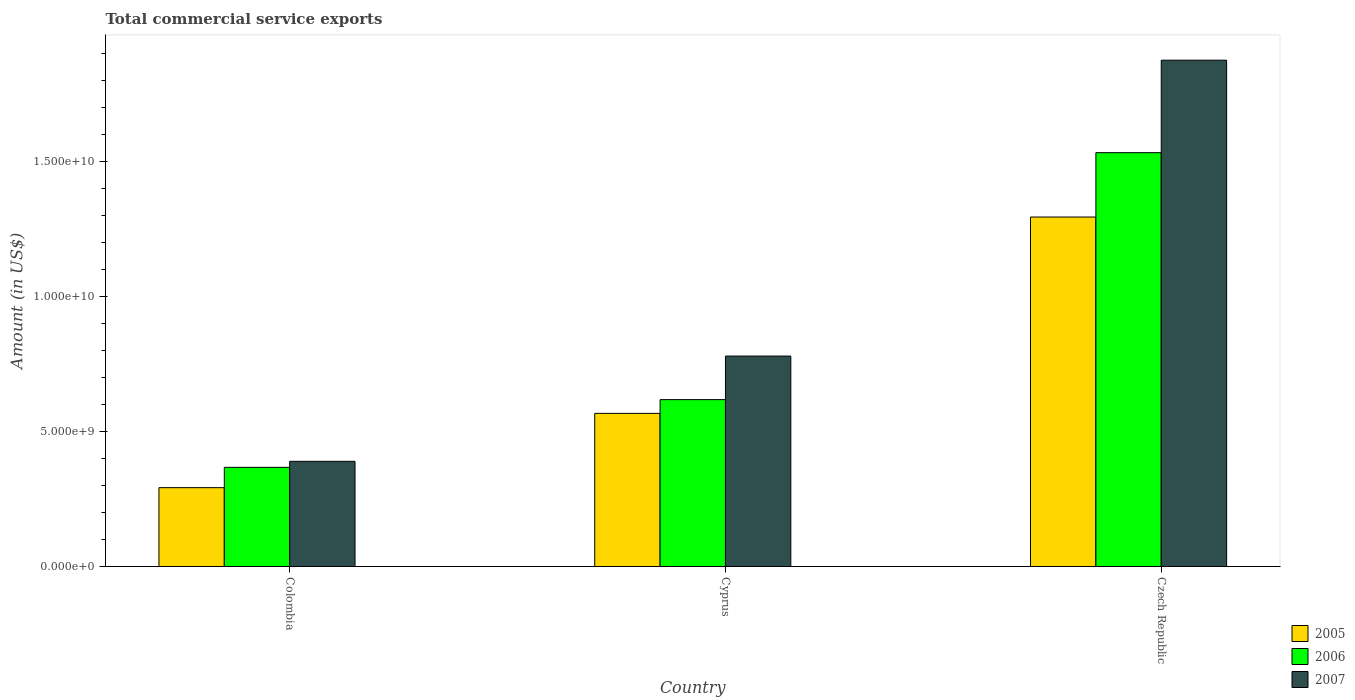Are the number of bars per tick equal to the number of legend labels?
Ensure brevity in your answer.  Yes. Are the number of bars on each tick of the X-axis equal?
Your answer should be compact. Yes. How many bars are there on the 2nd tick from the right?
Your response must be concise. 3. What is the label of the 3rd group of bars from the left?
Provide a short and direct response. Czech Republic. What is the total commercial service exports in 2007 in Colombia?
Your answer should be compact. 3.90e+09. Across all countries, what is the maximum total commercial service exports in 2005?
Provide a succinct answer. 1.30e+1. Across all countries, what is the minimum total commercial service exports in 2007?
Provide a succinct answer. 3.90e+09. In which country was the total commercial service exports in 2006 maximum?
Provide a succinct answer. Czech Republic. What is the total total commercial service exports in 2005 in the graph?
Provide a short and direct response. 2.16e+1. What is the difference between the total commercial service exports in 2007 in Cyprus and that in Czech Republic?
Offer a very short reply. -1.10e+1. What is the difference between the total commercial service exports in 2005 in Colombia and the total commercial service exports in 2006 in Czech Republic?
Your response must be concise. -1.24e+1. What is the average total commercial service exports in 2005 per country?
Provide a succinct answer. 7.18e+09. What is the difference between the total commercial service exports of/in 2006 and total commercial service exports of/in 2005 in Czech Republic?
Ensure brevity in your answer.  2.39e+09. In how many countries, is the total commercial service exports in 2007 greater than 9000000000 US$?
Give a very brief answer. 1. What is the ratio of the total commercial service exports in 2007 in Colombia to that in Cyprus?
Ensure brevity in your answer.  0.5. Is the total commercial service exports in 2005 in Cyprus less than that in Czech Republic?
Offer a terse response. Yes. Is the difference between the total commercial service exports in 2006 in Colombia and Cyprus greater than the difference between the total commercial service exports in 2005 in Colombia and Cyprus?
Provide a succinct answer. Yes. What is the difference between the highest and the second highest total commercial service exports in 2005?
Your response must be concise. 2.75e+09. What is the difference between the highest and the lowest total commercial service exports in 2006?
Offer a very short reply. 1.17e+1. What does the 3rd bar from the right in Colombia represents?
Provide a succinct answer. 2005. Is it the case that in every country, the sum of the total commercial service exports in 2005 and total commercial service exports in 2007 is greater than the total commercial service exports in 2006?
Provide a succinct answer. Yes. How many bars are there?
Give a very brief answer. 9. What is the difference between two consecutive major ticks on the Y-axis?
Make the answer very short. 5.00e+09. Are the values on the major ticks of Y-axis written in scientific E-notation?
Provide a succinct answer. Yes. Does the graph contain grids?
Your answer should be very brief. No. What is the title of the graph?
Keep it short and to the point. Total commercial service exports. What is the Amount (in US$) in 2005 in Colombia?
Your response must be concise. 2.92e+09. What is the Amount (in US$) of 2006 in Colombia?
Offer a very short reply. 3.68e+09. What is the Amount (in US$) in 2007 in Colombia?
Offer a very short reply. 3.90e+09. What is the Amount (in US$) of 2005 in Cyprus?
Give a very brief answer. 5.68e+09. What is the Amount (in US$) of 2006 in Cyprus?
Offer a very short reply. 6.19e+09. What is the Amount (in US$) in 2007 in Cyprus?
Offer a terse response. 7.80e+09. What is the Amount (in US$) of 2005 in Czech Republic?
Give a very brief answer. 1.30e+1. What is the Amount (in US$) in 2006 in Czech Republic?
Your answer should be very brief. 1.53e+1. What is the Amount (in US$) of 2007 in Czech Republic?
Ensure brevity in your answer.  1.88e+1. Across all countries, what is the maximum Amount (in US$) of 2005?
Your response must be concise. 1.30e+1. Across all countries, what is the maximum Amount (in US$) in 2006?
Give a very brief answer. 1.53e+1. Across all countries, what is the maximum Amount (in US$) in 2007?
Your answer should be compact. 1.88e+1. Across all countries, what is the minimum Amount (in US$) in 2005?
Your answer should be very brief. 2.92e+09. Across all countries, what is the minimum Amount (in US$) of 2006?
Give a very brief answer. 3.68e+09. Across all countries, what is the minimum Amount (in US$) in 2007?
Keep it short and to the point. 3.90e+09. What is the total Amount (in US$) of 2005 in the graph?
Provide a succinct answer. 2.16e+1. What is the total Amount (in US$) in 2006 in the graph?
Provide a short and direct response. 2.52e+1. What is the total Amount (in US$) of 2007 in the graph?
Give a very brief answer. 3.05e+1. What is the difference between the Amount (in US$) of 2005 in Colombia and that in Cyprus?
Your answer should be very brief. -2.75e+09. What is the difference between the Amount (in US$) in 2006 in Colombia and that in Cyprus?
Offer a terse response. -2.51e+09. What is the difference between the Amount (in US$) of 2007 in Colombia and that in Cyprus?
Your response must be concise. -3.90e+09. What is the difference between the Amount (in US$) of 2005 in Colombia and that in Czech Republic?
Keep it short and to the point. -1.00e+1. What is the difference between the Amount (in US$) in 2006 in Colombia and that in Czech Republic?
Give a very brief answer. -1.17e+1. What is the difference between the Amount (in US$) in 2007 in Colombia and that in Czech Republic?
Give a very brief answer. -1.49e+1. What is the difference between the Amount (in US$) of 2005 in Cyprus and that in Czech Republic?
Provide a short and direct response. -7.28e+09. What is the difference between the Amount (in US$) of 2006 in Cyprus and that in Czech Republic?
Your answer should be very brief. -9.16e+09. What is the difference between the Amount (in US$) in 2007 in Cyprus and that in Czech Republic?
Your answer should be very brief. -1.10e+1. What is the difference between the Amount (in US$) in 2005 in Colombia and the Amount (in US$) in 2006 in Cyprus?
Give a very brief answer. -3.26e+09. What is the difference between the Amount (in US$) of 2005 in Colombia and the Amount (in US$) of 2007 in Cyprus?
Ensure brevity in your answer.  -4.88e+09. What is the difference between the Amount (in US$) in 2006 in Colombia and the Amount (in US$) in 2007 in Cyprus?
Your answer should be compact. -4.13e+09. What is the difference between the Amount (in US$) in 2005 in Colombia and the Amount (in US$) in 2006 in Czech Republic?
Keep it short and to the point. -1.24e+1. What is the difference between the Amount (in US$) of 2005 in Colombia and the Amount (in US$) of 2007 in Czech Republic?
Your response must be concise. -1.58e+1. What is the difference between the Amount (in US$) of 2006 in Colombia and the Amount (in US$) of 2007 in Czech Republic?
Offer a very short reply. -1.51e+1. What is the difference between the Amount (in US$) in 2005 in Cyprus and the Amount (in US$) in 2006 in Czech Republic?
Offer a very short reply. -9.66e+09. What is the difference between the Amount (in US$) of 2005 in Cyprus and the Amount (in US$) of 2007 in Czech Republic?
Make the answer very short. -1.31e+1. What is the difference between the Amount (in US$) of 2006 in Cyprus and the Amount (in US$) of 2007 in Czech Republic?
Offer a terse response. -1.26e+1. What is the average Amount (in US$) in 2005 per country?
Provide a succinct answer. 7.18e+09. What is the average Amount (in US$) in 2006 per country?
Offer a very short reply. 8.40e+09. What is the average Amount (in US$) of 2007 per country?
Your answer should be compact. 1.02e+1. What is the difference between the Amount (in US$) of 2005 and Amount (in US$) of 2006 in Colombia?
Provide a succinct answer. -7.54e+08. What is the difference between the Amount (in US$) in 2005 and Amount (in US$) in 2007 in Colombia?
Make the answer very short. -9.77e+08. What is the difference between the Amount (in US$) of 2006 and Amount (in US$) of 2007 in Colombia?
Your answer should be compact. -2.23e+08. What is the difference between the Amount (in US$) in 2005 and Amount (in US$) in 2006 in Cyprus?
Provide a short and direct response. -5.09e+08. What is the difference between the Amount (in US$) in 2005 and Amount (in US$) in 2007 in Cyprus?
Your answer should be very brief. -2.12e+09. What is the difference between the Amount (in US$) in 2006 and Amount (in US$) in 2007 in Cyprus?
Offer a terse response. -1.62e+09. What is the difference between the Amount (in US$) of 2005 and Amount (in US$) of 2006 in Czech Republic?
Your answer should be compact. -2.39e+09. What is the difference between the Amount (in US$) in 2005 and Amount (in US$) in 2007 in Czech Republic?
Offer a terse response. -5.81e+09. What is the difference between the Amount (in US$) in 2006 and Amount (in US$) in 2007 in Czech Republic?
Offer a very short reply. -3.43e+09. What is the ratio of the Amount (in US$) in 2005 in Colombia to that in Cyprus?
Ensure brevity in your answer.  0.51. What is the ratio of the Amount (in US$) in 2006 in Colombia to that in Cyprus?
Offer a terse response. 0.59. What is the ratio of the Amount (in US$) in 2007 in Colombia to that in Cyprus?
Provide a succinct answer. 0.5. What is the ratio of the Amount (in US$) of 2005 in Colombia to that in Czech Republic?
Make the answer very short. 0.23. What is the ratio of the Amount (in US$) in 2006 in Colombia to that in Czech Republic?
Offer a very short reply. 0.24. What is the ratio of the Amount (in US$) in 2007 in Colombia to that in Czech Republic?
Your response must be concise. 0.21. What is the ratio of the Amount (in US$) of 2005 in Cyprus to that in Czech Republic?
Ensure brevity in your answer.  0.44. What is the ratio of the Amount (in US$) in 2006 in Cyprus to that in Czech Republic?
Ensure brevity in your answer.  0.4. What is the ratio of the Amount (in US$) in 2007 in Cyprus to that in Czech Republic?
Your response must be concise. 0.42. What is the difference between the highest and the second highest Amount (in US$) of 2005?
Make the answer very short. 7.28e+09. What is the difference between the highest and the second highest Amount (in US$) of 2006?
Your answer should be very brief. 9.16e+09. What is the difference between the highest and the second highest Amount (in US$) in 2007?
Make the answer very short. 1.10e+1. What is the difference between the highest and the lowest Amount (in US$) of 2005?
Provide a short and direct response. 1.00e+1. What is the difference between the highest and the lowest Amount (in US$) of 2006?
Give a very brief answer. 1.17e+1. What is the difference between the highest and the lowest Amount (in US$) of 2007?
Offer a terse response. 1.49e+1. 